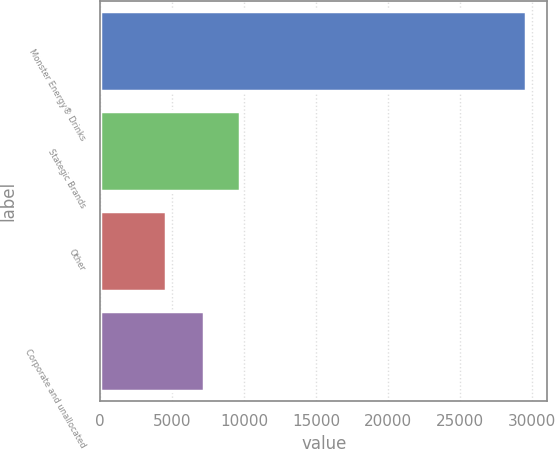<chart> <loc_0><loc_0><loc_500><loc_500><bar_chart><fcel>Monster Energy® Drinks<fcel>Stategic Brands<fcel>Other<fcel>Corporate and unallocated<nl><fcel>29591<fcel>9743.3<fcel>4608<fcel>7245<nl></chart> 